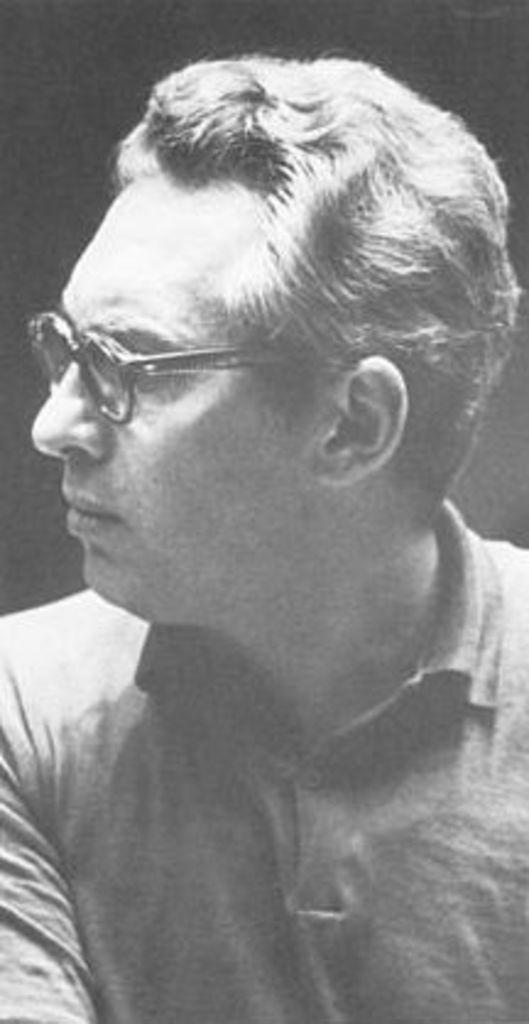In one or two sentences, can you explain what this image depicts? This picture is in black and white. In the picture, there is a man wearing a t shirt and spectacles. 